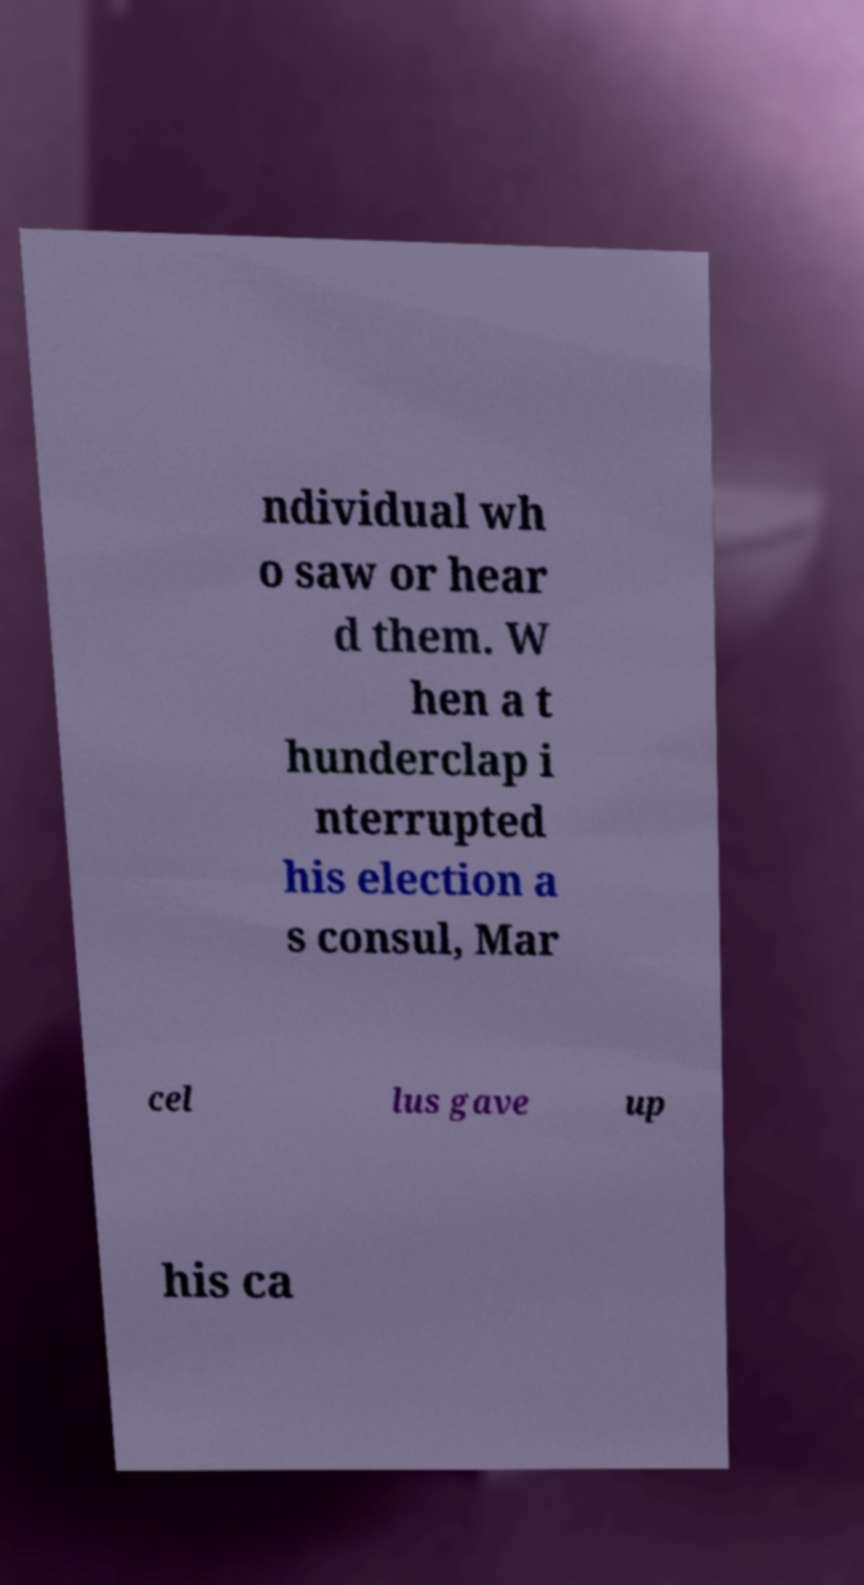What messages or text are displayed in this image? I need them in a readable, typed format. ndividual wh o saw or hear d them. W hen a t hunderclap i nterrupted his election a s consul, Mar cel lus gave up his ca 